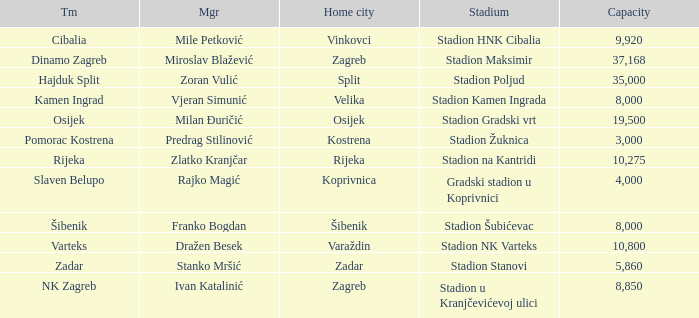What team has a home city of Koprivnica? Slaven Belupo. 